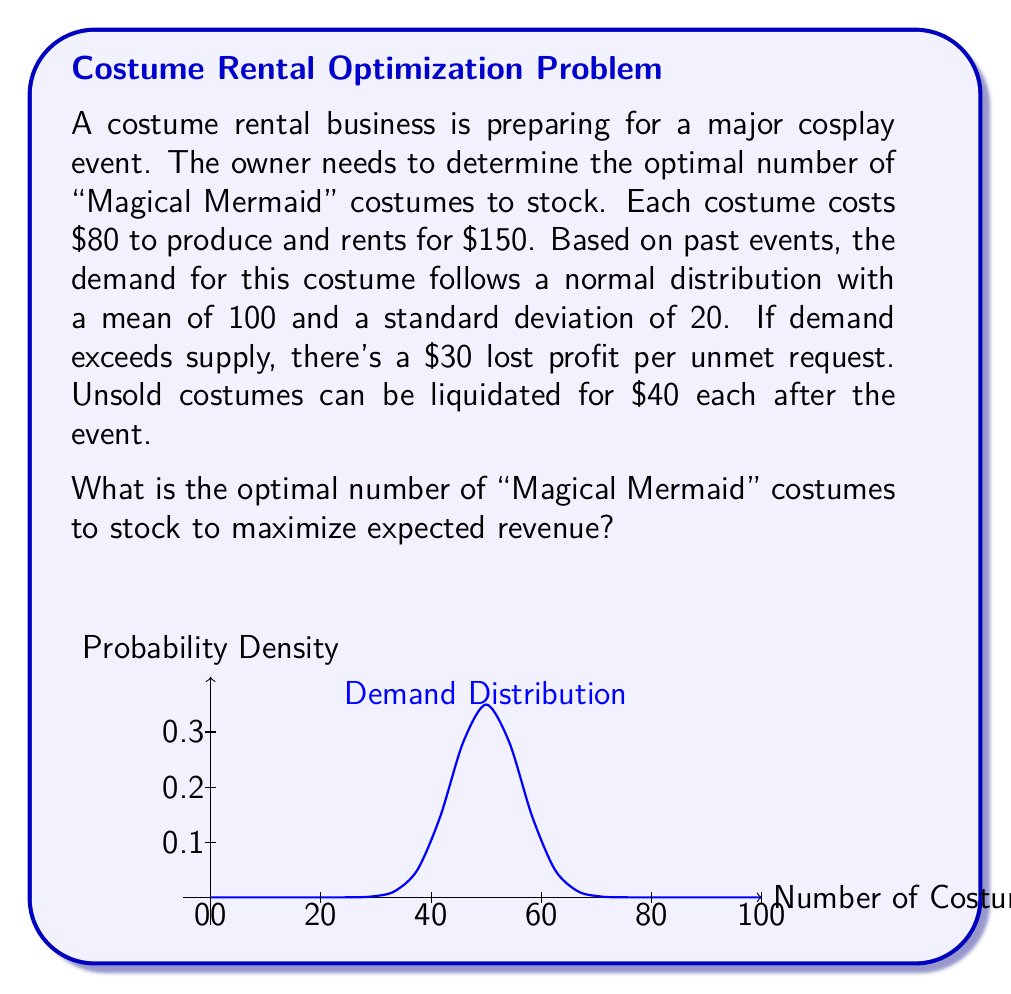Help me with this question. To solve this problem, we'll use the critical fractile method for the newsvendor problem. The steps are as follows:

1) Calculate the critical fractile (CF):
   $CF = \frac{p - c}{p - s}$
   Where:
   $p$ = selling price = $150
   $c$ = cost price = $80
   $s$ = salvage value = $40

   $CF = \frac{150 - 80}{150 - 40} = \frac{70}{110} \approx 0.6364$

2) Find the z-score corresponding to this fractile:
   Using the standard normal distribution table or a calculator, we find:
   $z \approx 0.35$

3) Calculate the optimal stock quantity:
   $Q^* = \mu + z\sigma$
   Where:
   $\mu$ = mean demand = 100
   $\sigma$ = standard deviation of demand = 20

   $Q^* = 100 + 0.35 * 20 = 107$

4) Round to the nearest whole number as we can't stock fractional costumes:
   Optimal stock = 107 costumes

This quantity balances the cost of overstocking (having unsold costumes) with the cost of understocking (lost sales and goodwill).
Answer: 107 costumes 